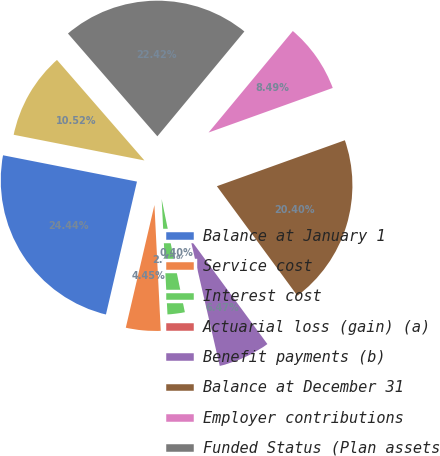Convert chart. <chart><loc_0><loc_0><loc_500><loc_500><pie_chart><fcel>Balance at January 1<fcel>Service cost<fcel>Interest cost<fcel>Actuarial loss (gain) (a)<fcel>Benefit payments (b)<fcel>Balance at December 31<fcel>Employer contributions<fcel>Funded Status (Plan assets<fcel>Unrecognized Net Actuarial<nl><fcel>24.44%<fcel>4.45%<fcel>2.42%<fcel>0.4%<fcel>6.47%<fcel>20.4%<fcel>8.49%<fcel>22.42%<fcel>10.52%<nl></chart> 